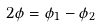<formula> <loc_0><loc_0><loc_500><loc_500>2 \phi = \phi _ { 1 } - \phi _ { 2 }</formula> 